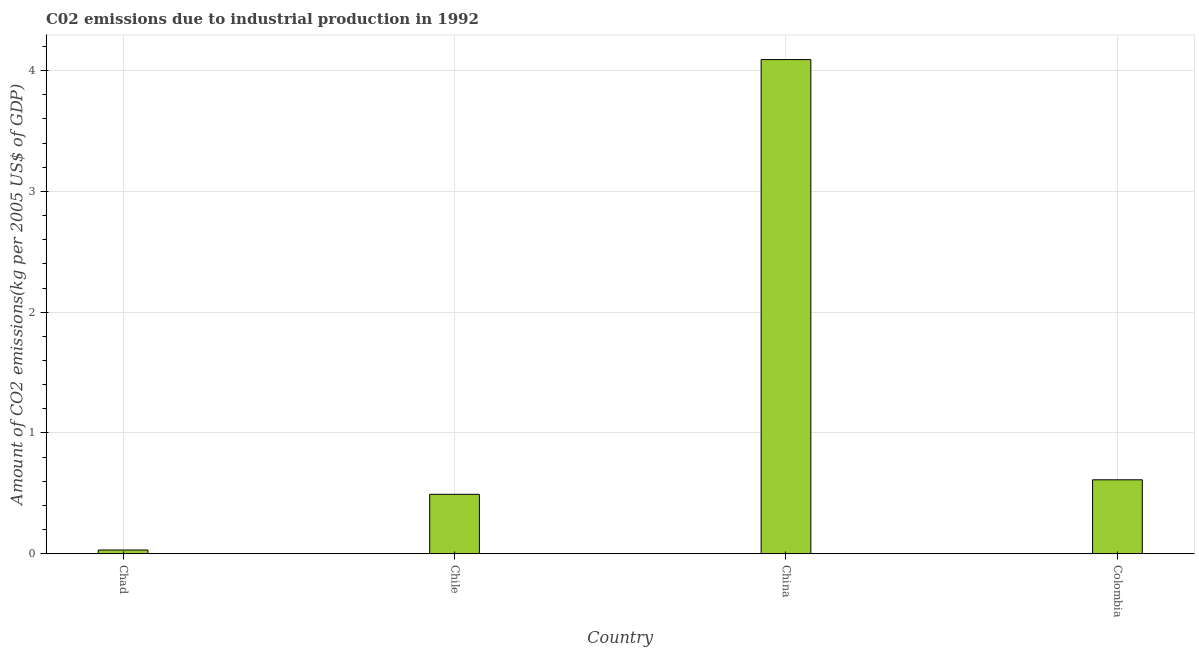Does the graph contain any zero values?
Make the answer very short. No. Does the graph contain grids?
Your answer should be very brief. Yes. What is the title of the graph?
Ensure brevity in your answer.  C02 emissions due to industrial production in 1992. What is the label or title of the Y-axis?
Ensure brevity in your answer.  Amount of CO2 emissions(kg per 2005 US$ of GDP). What is the amount of co2 emissions in China?
Give a very brief answer. 4.09. Across all countries, what is the maximum amount of co2 emissions?
Your answer should be very brief. 4.09. Across all countries, what is the minimum amount of co2 emissions?
Provide a succinct answer. 0.03. In which country was the amount of co2 emissions minimum?
Offer a very short reply. Chad. What is the sum of the amount of co2 emissions?
Provide a succinct answer. 5.23. What is the difference between the amount of co2 emissions in China and Colombia?
Your answer should be compact. 3.48. What is the average amount of co2 emissions per country?
Give a very brief answer. 1.31. What is the median amount of co2 emissions?
Provide a succinct answer. 0.55. In how many countries, is the amount of co2 emissions greater than 3.2 kg per 2005 US$ of GDP?
Keep it short and to the point. 1. What is the ratio of the amount of co2 emissions in Chile to that in Colombia?
Ensure brevity in your answer.  0.8. Is the amount of co2 emissions in Chad less than that in Chile?
Offer a terse response. Yes. What is the difference between the highest and the second highest amount of co2 emissions?
Offer a terse response. 3.48. Is the sum of the amount of co2 emissions in Chile and Colombia greater than the maximum amount of co2 emissions across all countries?
Keep it short and to the point. No. What is the difference between the highest and the lowest amount of co2 emissions?
Offer a terse response. 4.06. What is the difference between two consecutive major ticks on the Y-axis?
Provide a short and direct response. 1. What is the Amount of CO2 emissions(kg per 2005 US$ of GDP) in Chad?
Your response must be concise. 0.03. What is the Amount of CO2 emissions(kg per 2005 US$ of GDP) of Chile?
Your answer should be compact. 0.49. What is the Amount of CO2 emissions(kg per 2005 US$ of GDP) of China?
Provide a succinct answer. 4.09. What is the Amount of CO2 emissions(kg per 2005 US$ of GDP) in Colombia?
Give a very brief answer. 0.61. What is the difference between the Amount of CO2 emissions(kg per 2005 US$ of GDP) in Chad and Chile?
Offer a terse response. -0.46. What is the difference between the Amount of CO2 emissions(kg per 2005 US$ of GDP) in Chad and China?
Offer a terse response. -4.06. What is the difference between the Amount of CO2 emissions(kg per 2005 US$ of GDP) in Chad and Colombia?
Provide a short and direct response. -0.58. What is the difference between the Amount of CO2 emissions(kg per 2005 US$ of GDP) in Chile and China?
Offer a very short reply. -3.6. What is the difference between the Amount of CO2 emissions(kg per 2005 US$ of GDP) in Chile and Colombia?
Offer a terse response. -0.12. What is the difference between the Amount of CO2 emissions(kg per 2005 US$ of GDP) in China and Colombia?
Provide a succinct answer. 3.48. What is the ratio of the Amount of CO2 emissions(kg per 2005 US$ of GDP) in Chad to that in Chile?
Your response must be concise. 0.06. What is the ratio of the Amount of CO2 emissions(kg per 2005 US$ of GDP) in Chad to that in China?
Offer a terse response. 0.01. What is the ratio of the Amount of CO2 emissions(kg per 2005 US$ of GDP) in Chad to that in Colombia?
Your response must be concise. 0.05. What is the ratio of the Amount of CO2 emissions(kg per 2005 US$ of GDP) in Chile to that in China?
Keep it short and to the point. 0.12. What is the ratio of the Amount of CO2 emissions(kg per 2005 US$ of GDP) in Chile to that in Colombia?
Ensure brevity in your answer.  0.8. What is the ratio of the Amount of CO2 emissions(kg per 2005 US$ of GDP) in China to that in Colombia?
Give a very brief answer. 6.68. 